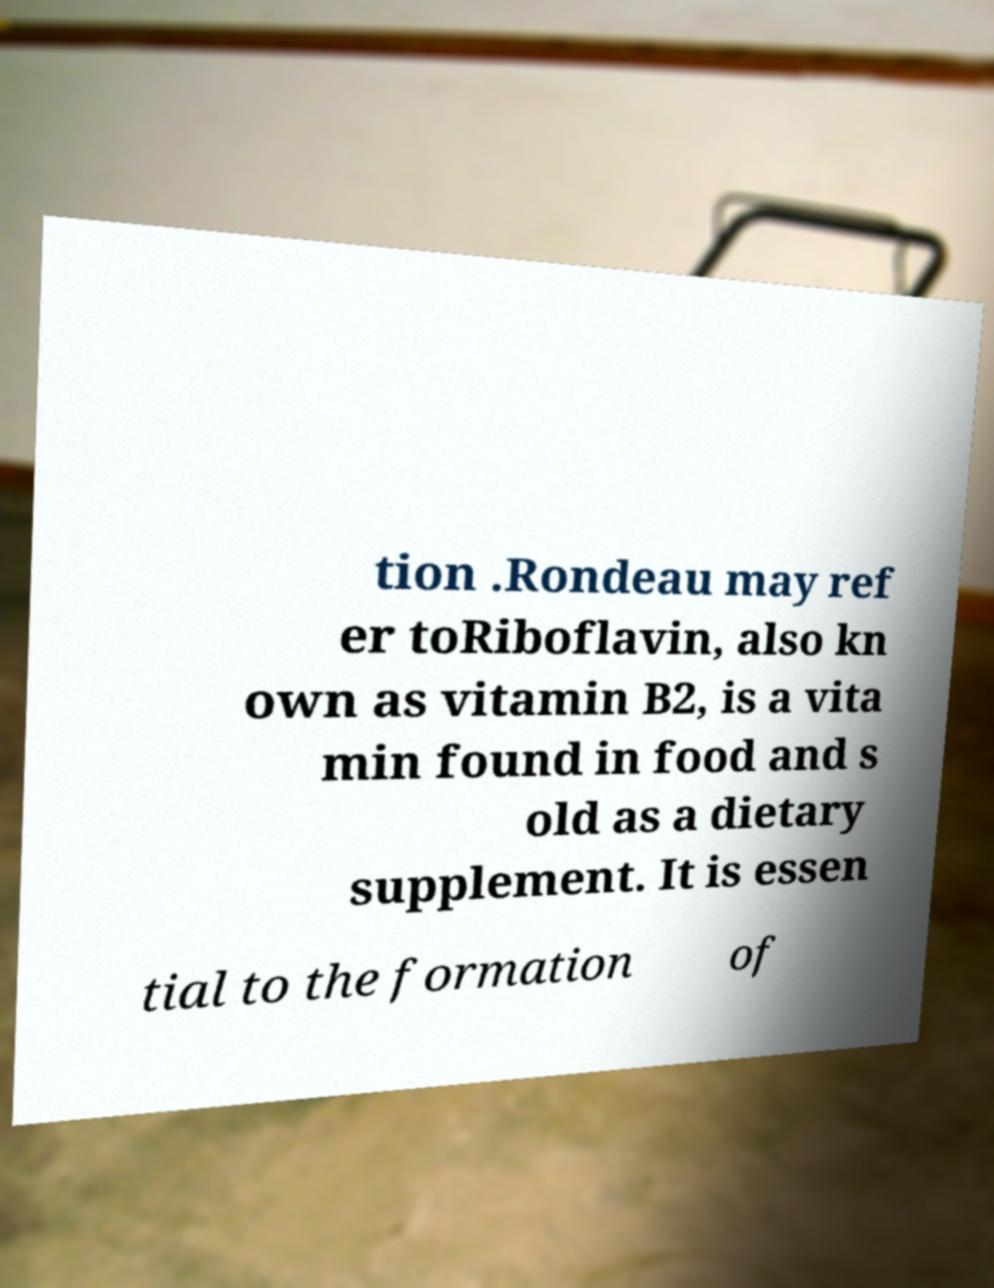Can you accurately transcribe the text from the provided image for me? tion .Rondeau may ref er toRiboflavin, also kn own as vitamin B2, is a vita min found in food and s old as a dietary supplement. It is essen tial to the formation of 